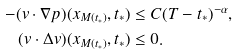<formula> <loc_0><loc_0><loc_500><loc_500>- ( v \cdot \nabla p ) ( x _ { M ( t _ { * } ) } , t _ { * } ) & \leq C ( T - t _ { * } ) ^ { - \alpha } , \\ ( v \cdot \Delta v ) ( x _ { M ( t _ { * } ) } , t _ { * } ) & \leq 0 .</formula> 